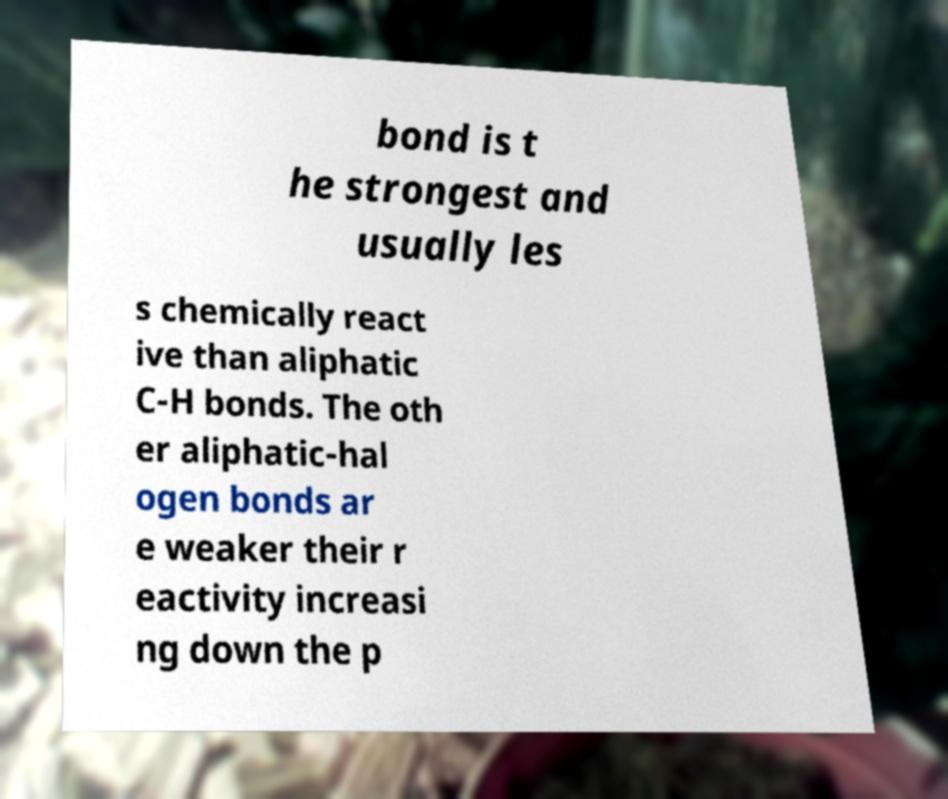Please read and relay the text visible in this image. What does it say? bond is t he strongest and usually les s chemically react ive than aliphatic C-H bonds. The oth er aliphatic-hal ogen bonds ar e weaker their r eactivity increasi ng down the p 